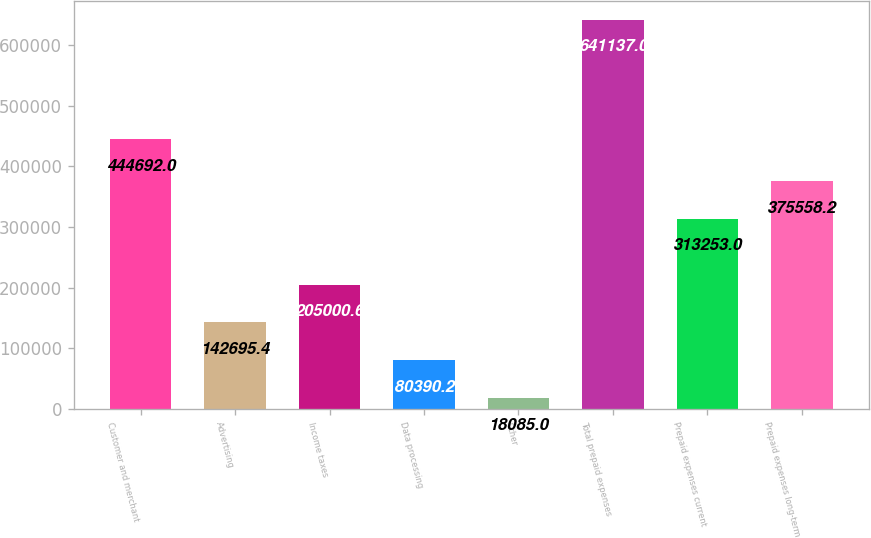Convert chart to OTSL. <chart><loc_0><loc_0><loc_500><loc_500><bar_chart><fcel>Customer and merchant<fcel>Advertising<fcel>Income taxes<fcel>Data processing<fcel>Other<fcel>Total prepaid expenses<fcel>Prepaid expenses current<fcel>Prepaid expenses long-term<nl><fcel>444692<fcel>142695<fcel>205001<fcel>80390.2<fcel>18085<fcel>641137<fcel>313253<fcel>375558<nl></chart> 